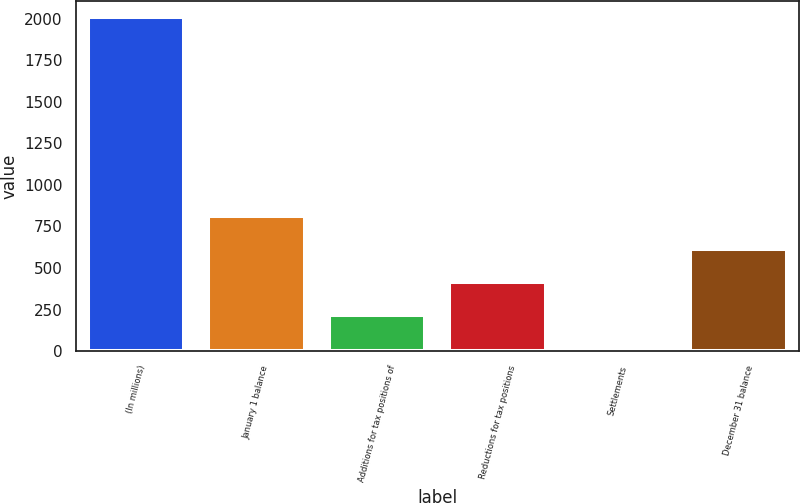Convert chart. <chart><loc_0><loc_0><loc_500><loc_500><bar_chart><fcel>(In millions)<fcel>January 1 balance<fcel>Additions for tax positions of<fcel>Reductions for tax positions<fcel>Settlements<fcel>December 31 balance<nl><fcel>2007<fcel>814.2<fcel>217.8<fcel>416.6<fcel>19<fcel>615.4<nl></chart> 